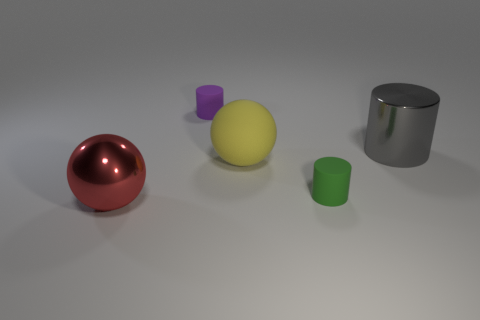Are there fewer large rubber balls than blue metallic objects? No, there are not fewer large rubber balls than blue metallic objects. The image shows one large rubber ball and one cylindrical blue metallic object, making them equal in number. 